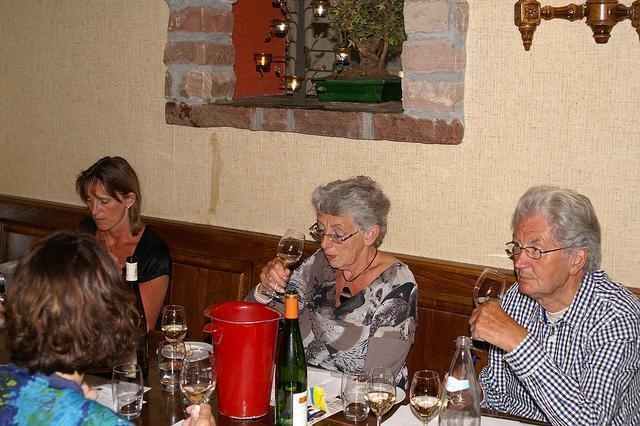How many elderly people are at the table?
Give a very brief answer. 2. How many bottles are there?
Give a very brief answer. 2. How many people can you see?
Give a very brief answer. 4. 